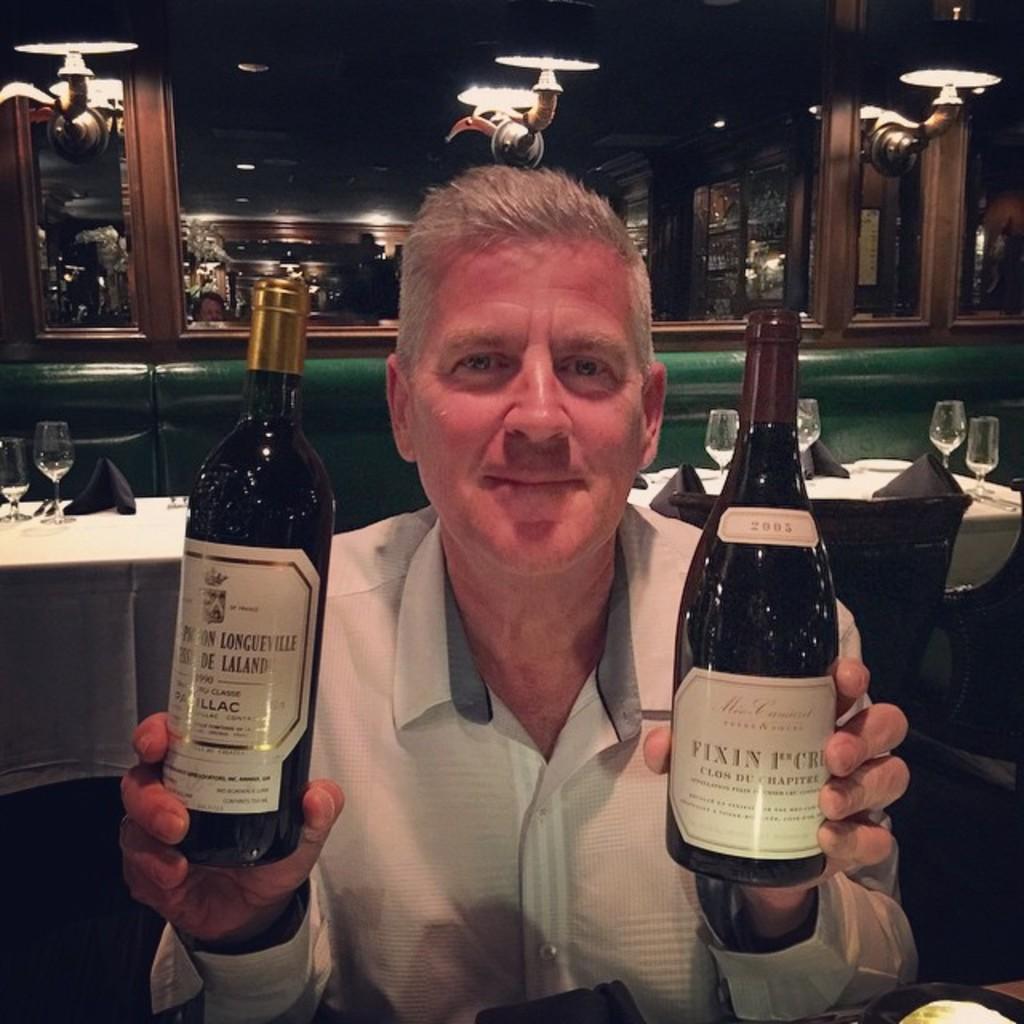In what year was the wine on the right made?
Give a very brief answer. 2005. What year was the wine on the left made?
Provide a short and direct response. Unanswerable. 